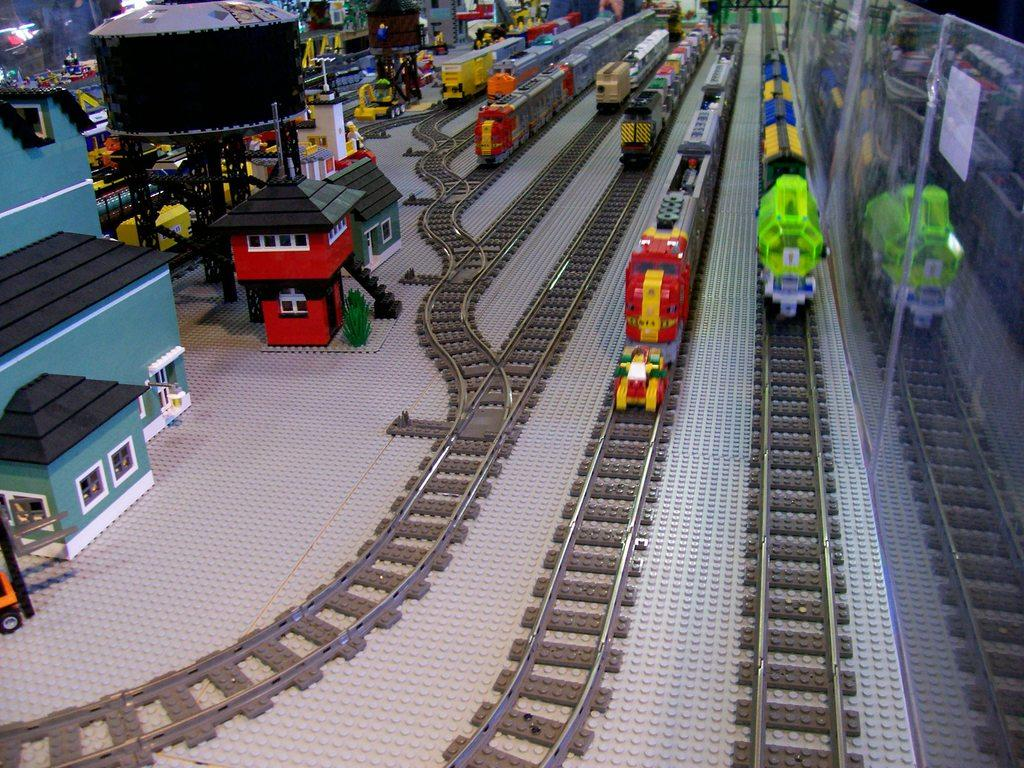What type of toys are present in the image? There are toy buildings, a water tank, toy trains on railway tracks, and colorful toys visible in the background of the image. What is the water tank used for in the image? The water tank is a toy and is not used for any real purpose in the image. What type of structure can be seen in the image? There are stairs in the image. How are the toy trains positioned in the image? The toy trains are on railway tracks in the image. What type of caption is written on the toy buildings in the image? There is no caption written on the toy buildings in the image; they are toys and do not have any text. How many dimes are visible on the stairs in the image? There are no dimes present in the image; it features toy buildings, a water tank, toy trains, stairs, and colorful toys. 